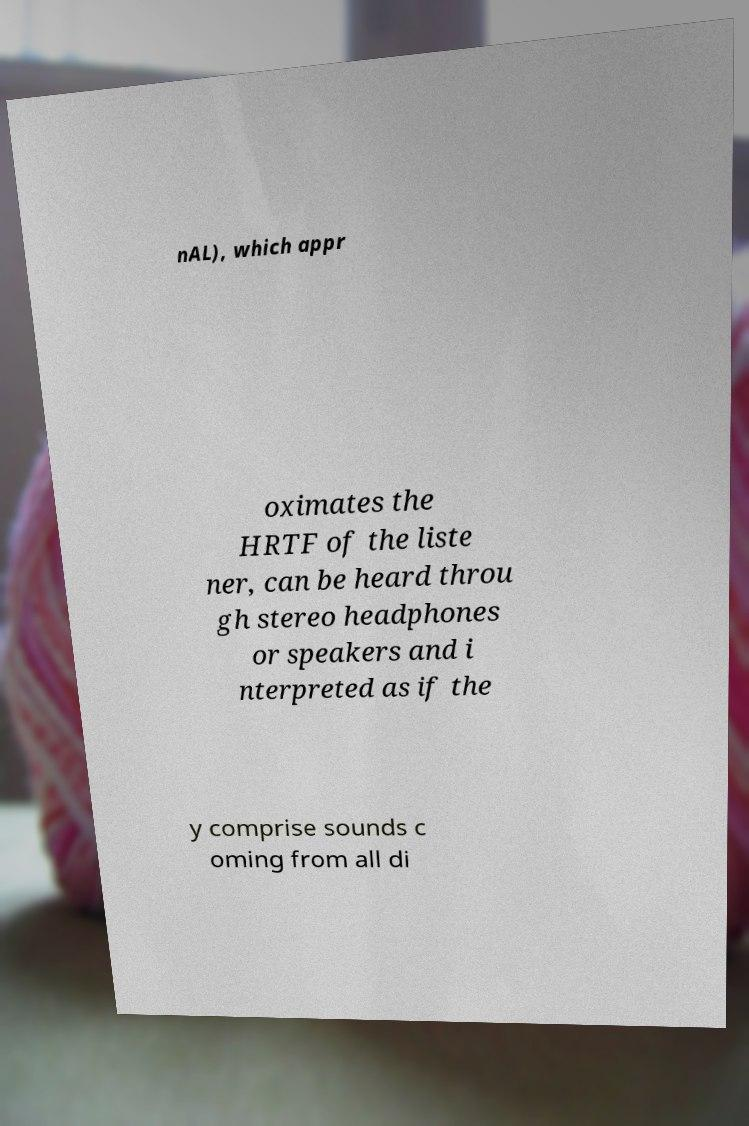For documentation purposes, I need the text within this image transcribed. Could you provide that? nAL), which appr oximates the HRTF of the liste ner, can be heard throu gh stereo headphones or speakers and i nterpreted as if the y comprise sounds c oming from all di 